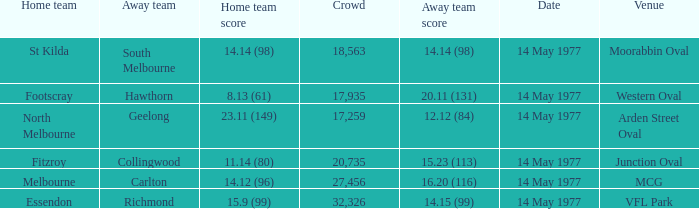I want to know the home team score of the away team of richmond that has a crowd more than 20,735 15.9 (99). 